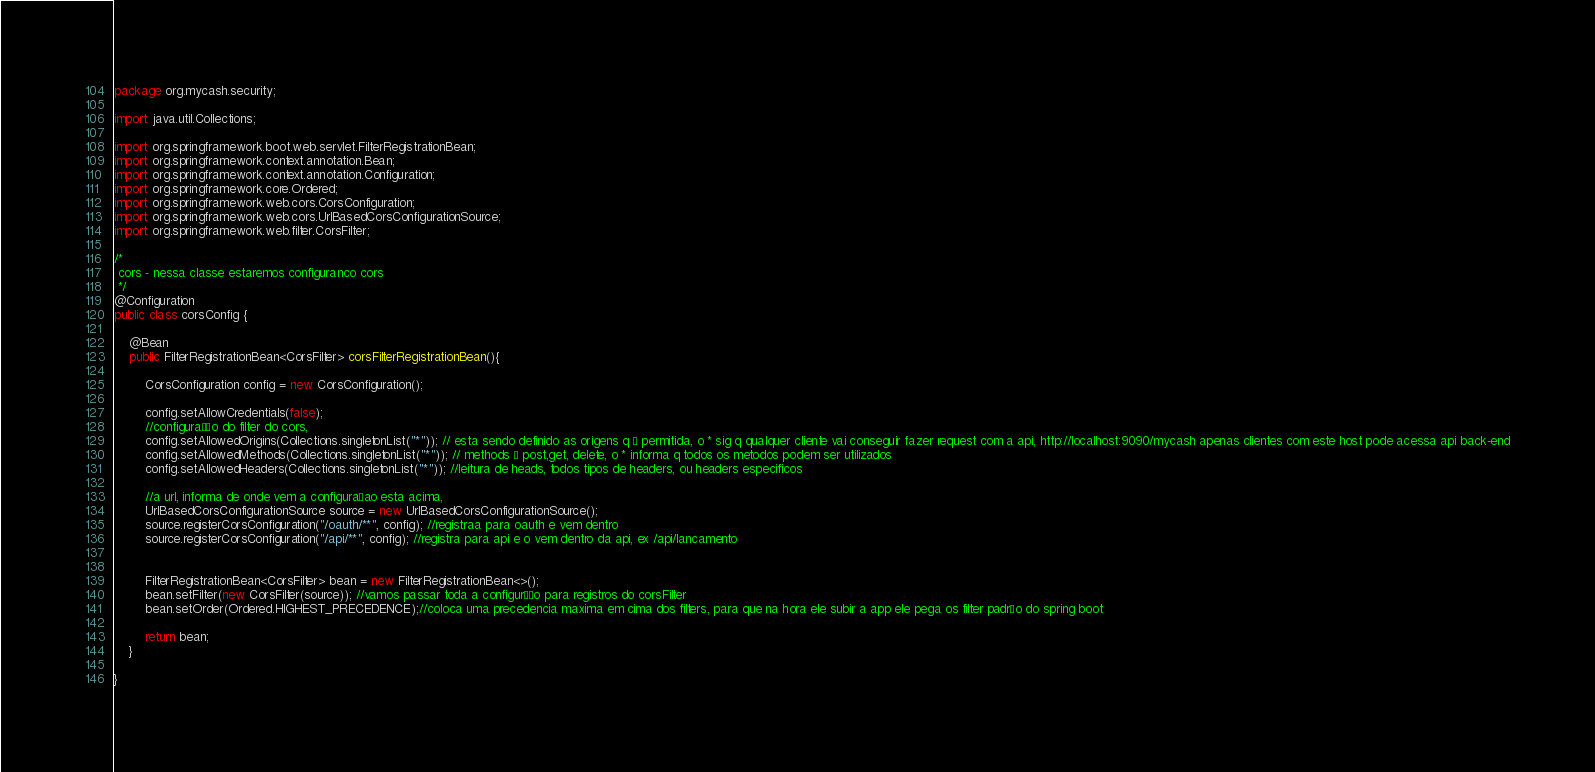Convert code to text. <code><loc_0><loc_0><loc_500><loc_500><_Java_>package org.mycash.security;

import java.util.Collections;

import org.springframework.boot.web.servlet.FilterRegistrationBean;
import org.springframework.context.annotation.Bean;
import org.springframework.context.annotation.Configuration;
import org.springframework.core.Ordered;
import org.springframework.web.cors.CorsConfiguration;
import org.springframework.web.cors.UrlBasedCorsConfigurationSource;
import org.springframework.web.filter.CorsFilter;

/*
 cors - nessa classe estaremos configuranco cors
 */
@Configuration
public class corsConfig {
	
	@Bean
	public FilterRegistrationBean<CorsFilter> corsFilterRegistrationBean(){
		
		CorsConfiguration config = new CorsConfiguration();
		
		config.setAllowCredentials(false);
		//configuração do filter do cors, 
		config.setAllowedOrigins(Collections.singletonList("*")); // esta sendo definido as origens q é permitida, o * sig q qualquer cliente vai conseguir fazer request com a api, http://localhost:9090/mycash apenas clientes com este host pode acessa api back-end
		config.setAllowedMethods(Collections.singletonList("*")); // methods é post,get, delete, o * informa q todos os metodos podem ser utilizados
		config.setAllowedHeaders(Collections.singletonList("*")); //leitura de heads, todos tipos de headers, ou headers especificos
		
		//a url, informa de onde vem a configuraçao esta acima,
		UrlBasedCorsConfigurationSource source = new UrlBasedCorsConfigurationSource();
		source.registerCorsConfiguration("/oauth/**", config); //registraa para oauth e vem dentro
		source.registerCorsConfiguration("/api/**", config); //registra para api e o vem dentro da api, ex /api/lancamento
		
		
		FilterRegistrationBean<CorsFilter> bean = new FilterRegistrationBean<>();
		bean.setFilter(new CorsFilter(source)); //vamos passar toda a configurção para registros do corsFilter
		bean.setOrder(Ordered.HIGHEST_PRECEDENCE);//coloca uma precedencia maxima em cima dos filters, para que na hora ele subir a app ele pega os filter padrão do spring boot
		
		return bean;
	}

}
</code> 